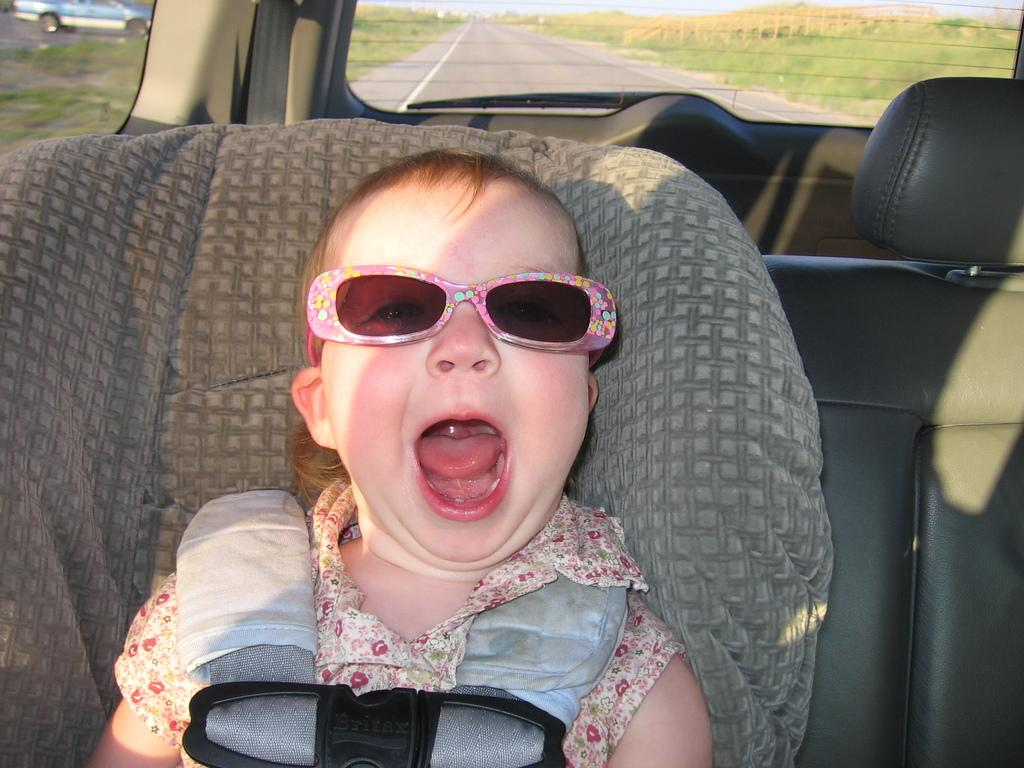What is the main subject of the image? There is a baby in the image. What is the baby wearing? The baby is wearing goggles. Where is the baby located? The baby is sitting inside a car. What can be seen on either side of the car? There is greenery on either side of the car. What is visible beneath the car? The ground is visible in the image. Can you see a goose flying over the coast in the image? There is no goose or coast present in the image; it features a baby sitting in a car with greenery on either side. 